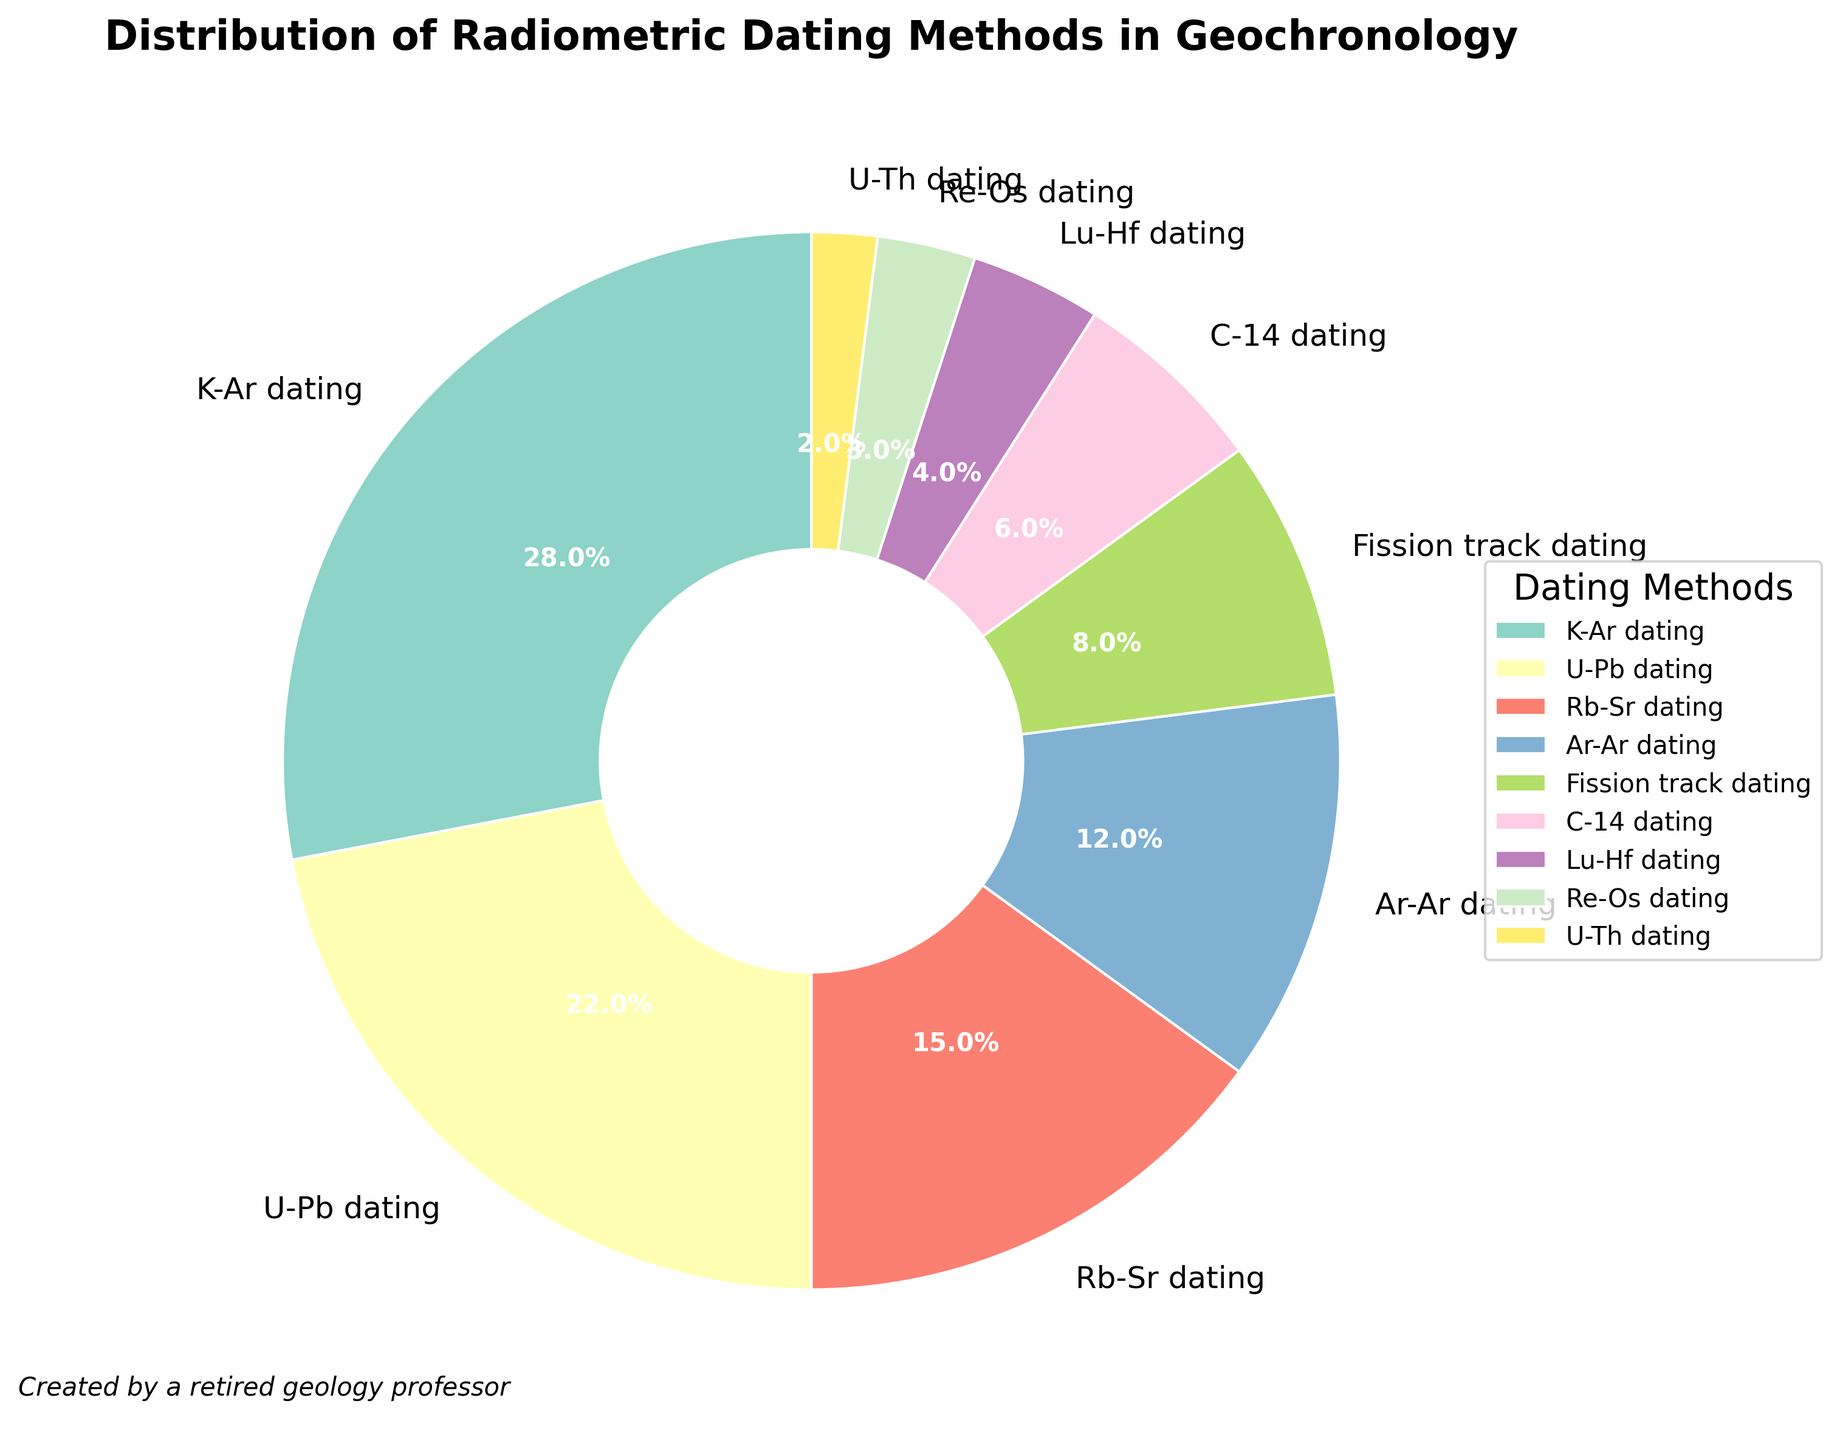What are the top three radiometric dating methods in terms of usage percentage? First, identify the percentages of each method. The top three methods are K-Ar dating with 28%, U-Pb dating with 22%, and Rb-Sr dating with 15%.
Answer: K-Ar dating, U-Pb dating, Rb-Sr dating Which radiometric dating method has the lowest usage percentage? Scan the percentages to find the smallest one. The smallest percentage is 2%, which corresponds to U-Th dating.
Answer: U-Th dating What is the total combined percentage for the methods Ar-Ar dating, Fission track dating, and C-14 dating? Add the percentages of the three methods: Ar-Ar dating (12%), Fission track dating (8%), and C-14 dating (6%). The sum is 12% + 8% + 6% = 26%.
Answer: 26% How much more popular is K-Ar dating compared to C-14 dating? Subtract the percentage of C-14 dating (6%) from the percentage of K-Ar dating (28%). The difference is 28% - 6% = 22%.
Answer: 22% Are there any methods with equal usage percentage? Scan the percentages to check for any duplicates. No percentages are the same, so no methods have equal usage percentages.
Answer: No Which methods combined make up approximately half of the total usage? Adding K-Ar dating (28%) and U-Pb dating (22%) gives 50%, which is around half of the total.
Answer: K-Ar dating and U-Pb dating How does the usage of Rb-Sr dating compare to Ar-Ar dating? Compare the percentages of Rb-Sr dating (15%) and Ar-Ar dating (12%). Rb-Sr dating is more widely used by 3%.
Answer: Rb-Sr dating is more widely used What is the difference in usage between Lu-Hf dating and Re-Os dating? Subtract Re-Os dating (3%) from Lu-Hf dating (4%). The difference is 4% - 3% = 1%.
Answer: 1% List all methods with a usage percentage under 10%. Identify methods with percentages less than 10%. These are Fission track dating (8%), C-14 dating (6%), Lu-Hf dating (4%), Re-Os dating (3%), and U-Th dating (2%).
Answer: Fission track dating, C-14 dating, Lu-Hf dating, Re-Os dating, U-Th dating 